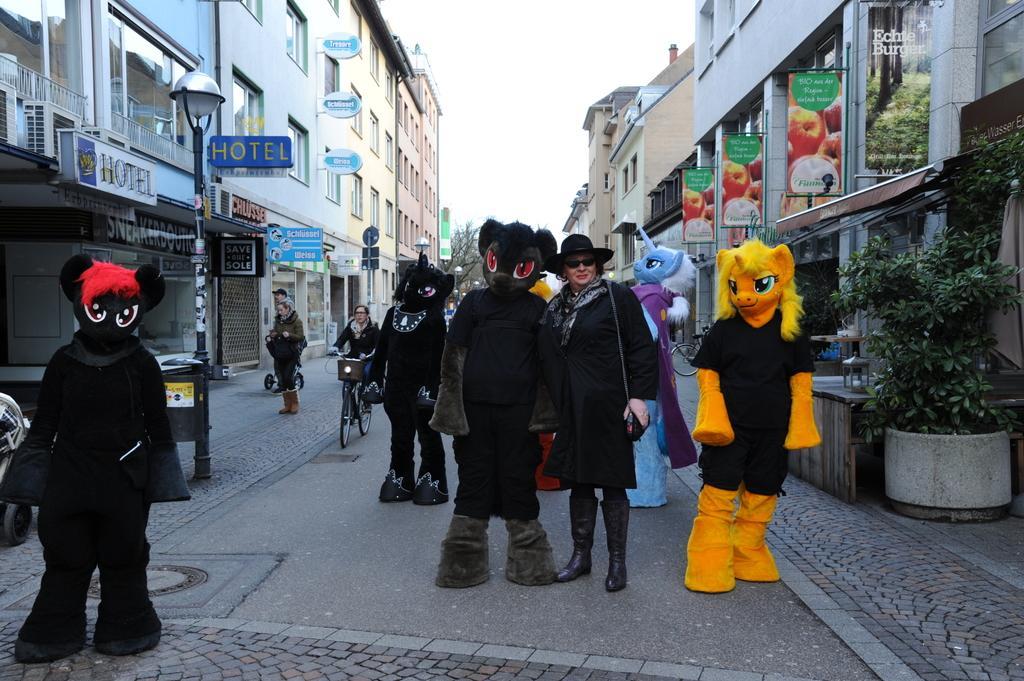Can you describe this image briefly? In this picture there are people, among them few people wore costumes and there is a woman riding bicycle. We can see plant with pot, boards, lights, buildings,box and poles. In the background of the image we can see trees and sky. 